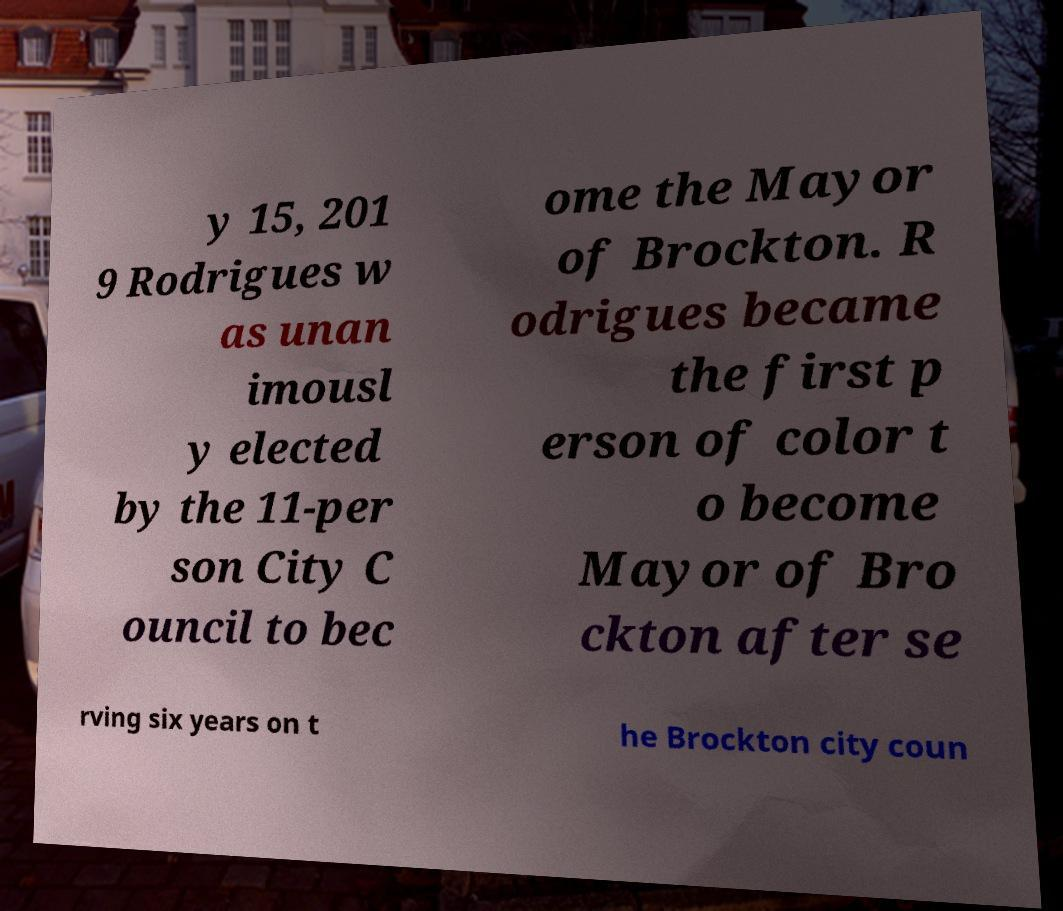Could you extract and type out the text from this image? y 15, 201 9 Rodrigues w as unan imousl y elected by the 11-per son City C ouncil to bec ome the Mayor of Brockton. R odrigues became the first p erson of color t o become Mayor of Bro ckton after se rving six years on t he Brockton city coun 